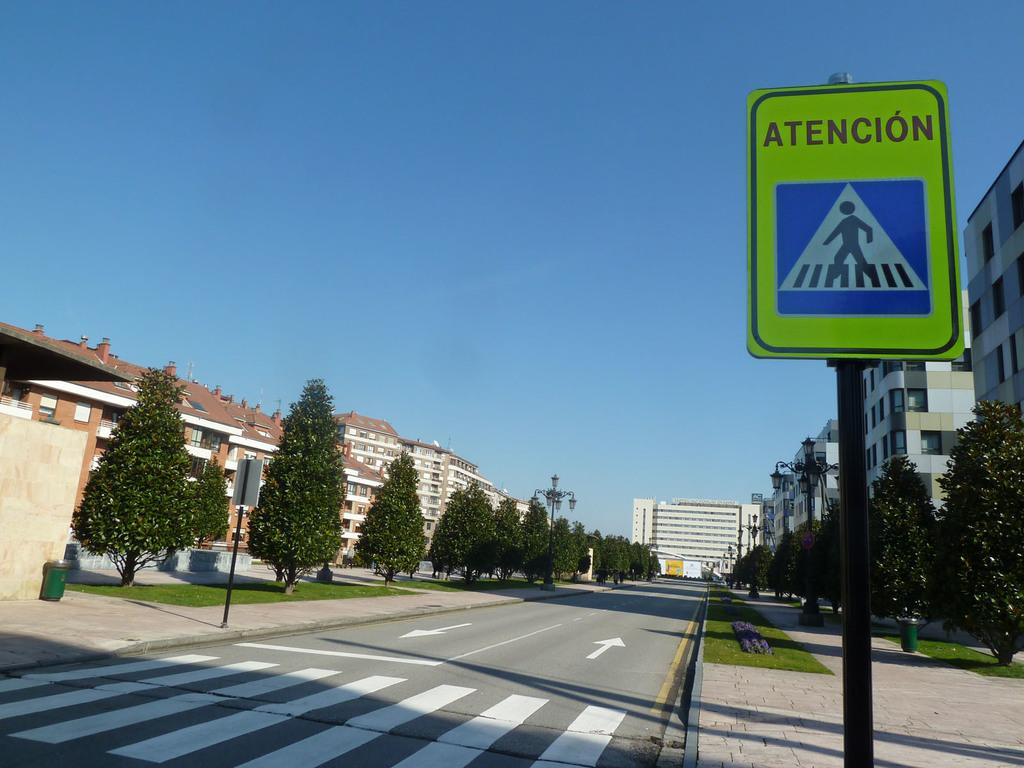<image>
Provide a brief description of the given image. A neon yellow street sign on the side of the road alerts drivers to pedestrians crossing by reading attention, in another language. 